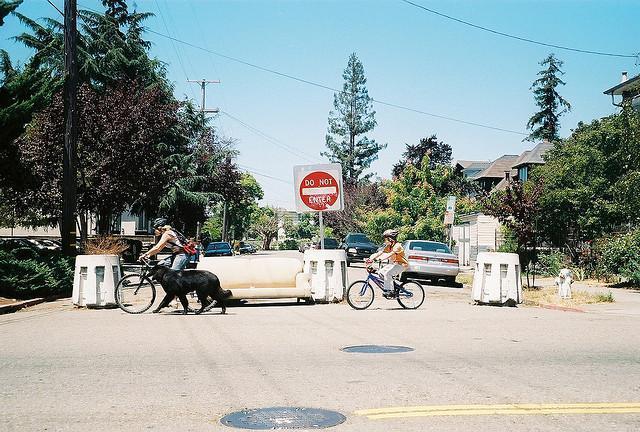How many bicycles are in the picture?
Give a very brief answer. 2. How many elephants are there?
Give a very brief answer. 0. 